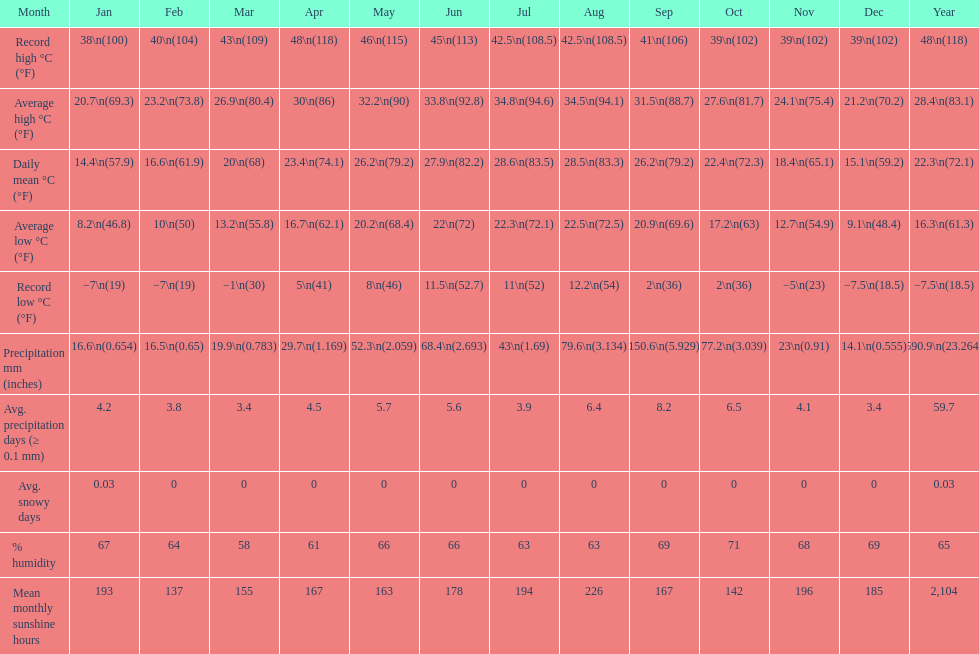In comparing december and january, which one typically has a greater amount of snow days? January. 